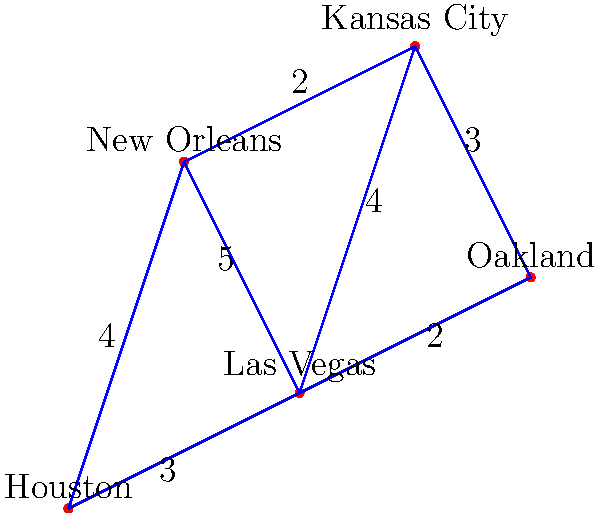Given the graph representing NFL stadiums where Derek Carr has played, with edge weights representing travel distances (in hours), what is the shortest path from Las Vegas to Houston, and what is its total duration? To find the shortest path from Las Vegas to Houston, we'll use Dijkstra's algorithm:

1. Start at Las Vegas (source node).
2. Initialize distances: Las Vegas (0), Oakland (2), Kansas City (4), New Orleans (5), Houston (3).
3. Visit the unvisited node with the smallest distance (Houston, 3).
4. Update distances through Houston:
   - Las Vegas to New Orleans via Houston: 3 + 4 = 7 (not shorter)
5. All nodes connected to Las Vegas are visited, algorithm terminates.

The shortest path from Las Vegas to Houston is the direct route, taking 3 hours.

To verify:
- Las Vegas to Oakland to Kansas City to Houston: 2 + 3 + 4 = 9 hours
- Las Vegas to Kansas City to New Orleans to Houston: 4 + 2 + 4 = 10 hours
- Las Vegas to New Orleans to Houston: 5 + 4 = 9 hours

The direct path (3 hours) is indeed the shortest.
Answer: Direct path: Las Vegas to Houston, 3 hours 